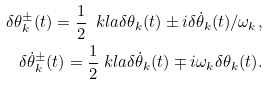<formula> <loc_0><loc_0><loc_500><loc_500>\delta \theta _ { k } ^ { \pm } ( t ) = \frac { 1 } { 2 } \ k l a { \delta \theta _ { k } ( t ) \pm i \delta \dot { \theta } _ { k } ( t ) / \omega _ { k } } , \\ \delta \dot { \theta } _ { k } ^ { \pm } ( t ) = \frac { 1 } { 2 } \ k l a { \delta \dot { \theta } _ { k } ( t ) \mp i \omega _ { k } \delta \theta _ { k } ( t ) } .</formula> 